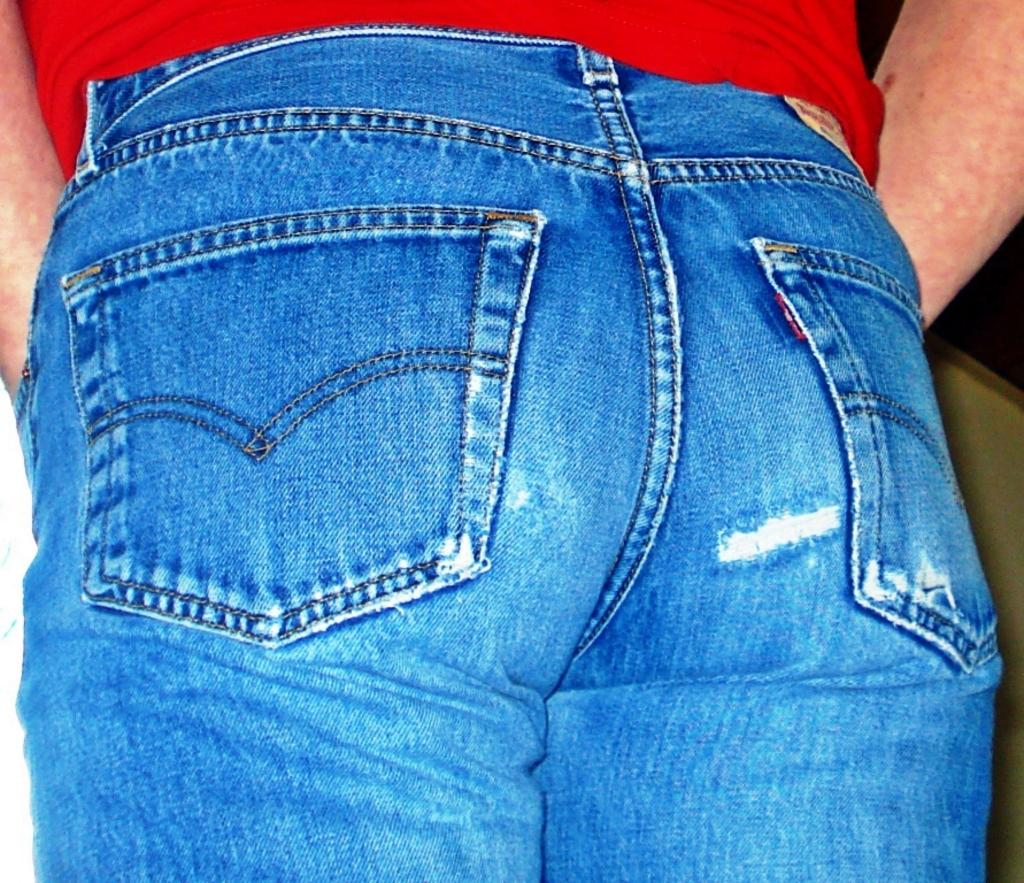Who or what is present in the image? There is a person in the image. What type of clothing is the person wearing? The person is wearing jeans. What color or pattern can be seen in the image? There is a red cloth in the image. Can you describe the background of the image? There is an object in the background of the image. How many thumbs can be seen on the person's hands in the image? There is no information provided about the person's thumbs in the image, so it cannot be determined. 